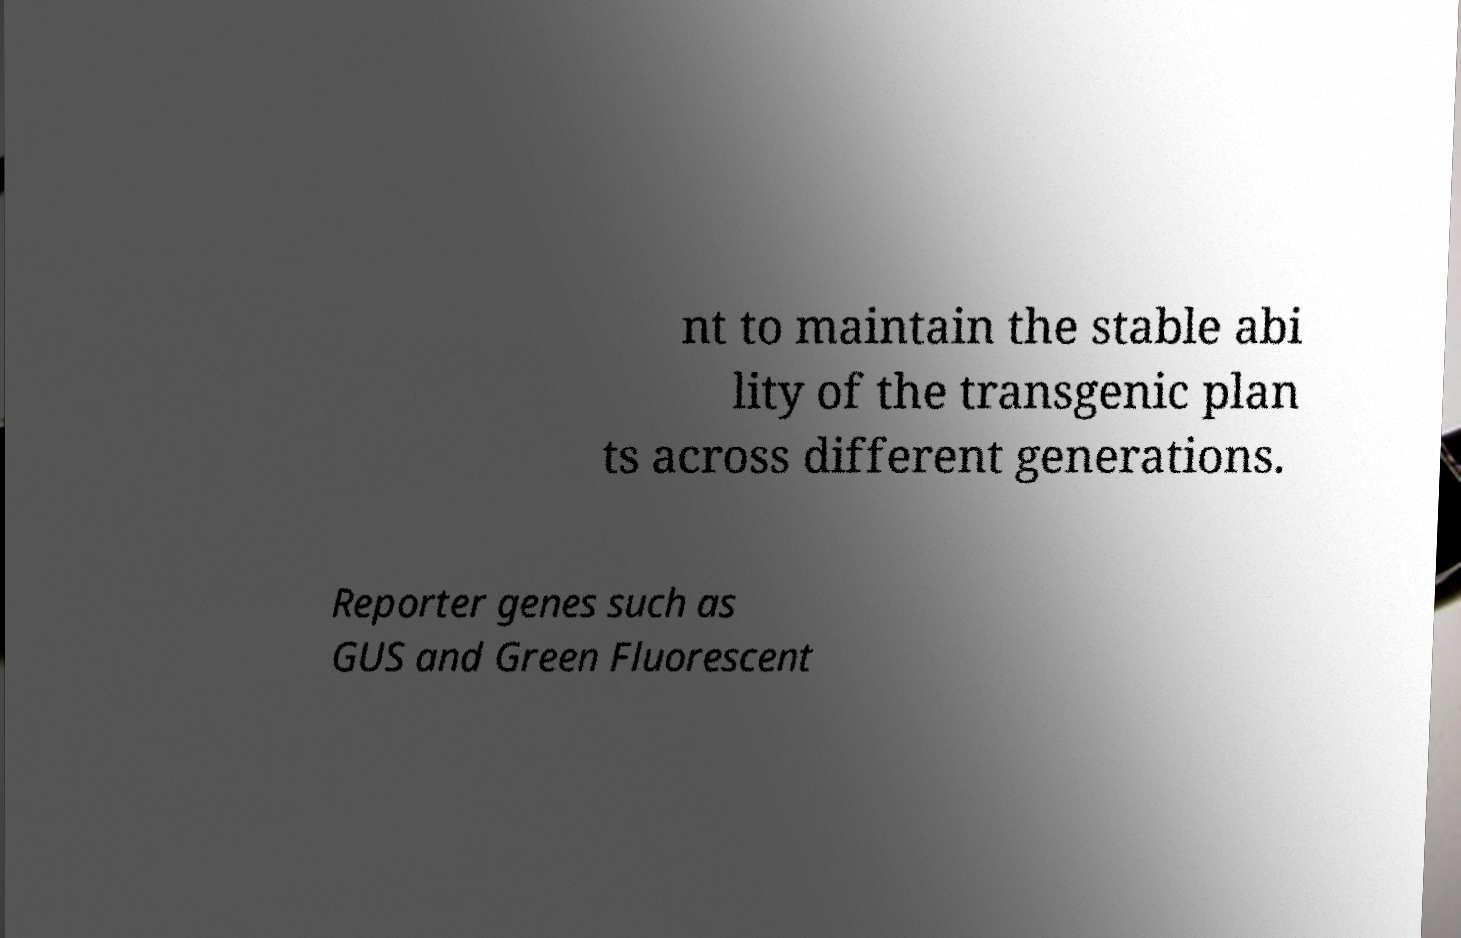Could you extract and type out the text from this image? nt to maintain the stable abi lity of the transgenic plan ts across different generations. Reporter genes such as GUS and Green Fluorescent 